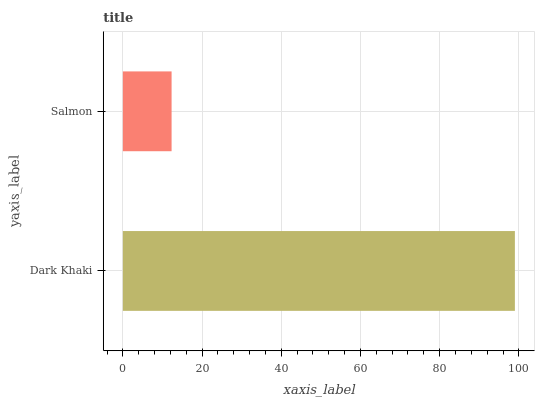Is Salmon the minimum?
Answer yes or no. Yes. Is Dark Khaki the maximum?
Answer yes or no. Yes. Is Salmon the maximum?
Answer yes or no. No. Is Dark Khaki greater than Salmon?
Answer yes or no. Yes. Is Salmon less than Dark Khaki?
Answer yes or no. Yes. Is Salmon greater than Dark Khaki?
Answer yes or no. No. Is Dark Khaki less than Salmon?
Answer yes or no. No. Is Dark Khaki the high median?
Answer yes or no. Yes. Is Salmon the low median?
Answer yes or no. Yes. Is Salmon the high median?
Answer yes or no. No. Is Dark Khaki the low median?
Answer yes or no. No. 